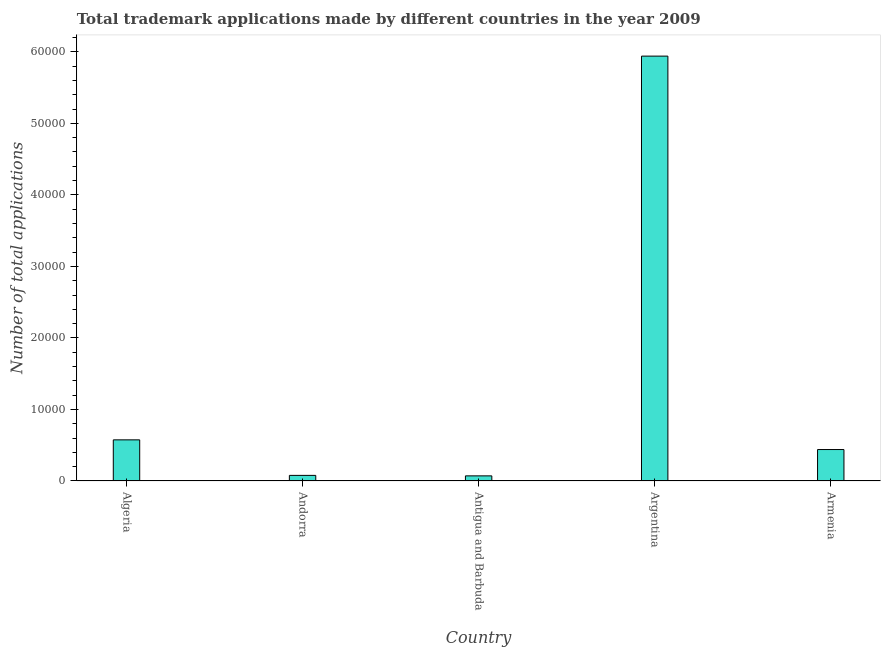Does the graph contain any zero values?
Provide a short and direct response. No. What is the title of the graph?
Your answer should be very brief. Total trademark applications made by different countries in the year 2009. What is the label or title of the X-axis?
Provide a succinct answer. Country. What is the label or title of the Y-axis?
Provide a short and direct response. Number of total applications. What is the number of trademark applications in Antigua and Barbuda?
Your response must be concise. 716. Across all countries, what is the maximum number of trademark applications?
Make the answer very short. 5.94e+04. Across all countries, what is the minimum number of trademark applications?
Ensure brevity in your answer.  716. In which country was the number of trademark applications maximum?
Provide a succinct answer. Argentina. In which country was the number of trademark applications minimum?
Your answer should be compact. Antigua and Barbuda. What is the sum of the number of trademark applications?
Offer a terse response. 7.11e+04. What is the difference between the number of trademark applications in Andorra and Argentina?
Make the answer very short. -5.86e+04. What is the average number of trademark applications per country?
Offer a terse response. 1.42e+04. What is the median number of trademark applications?
Provide a short and direct response. 4398. What is the ratio of the number of trademark applications in Argentina to that in Armenia?
Provide a short and direct response. 13.51. Is the number of trademark applications in Andorra less than that in Antigua and Barbuda?
Provide a short and direct response. No. Is the difference between the number of trademark applications in Algeria and Armenia greater than the difference between any two countries?
Provide a succinct answer. No. What is the difference between the highest and the second highest number of trademark applications?
Offer a terse response. 5.37e+04. Is the sum of the number of trademark applications in Andorra and Antigua and Barbuda greater than the maximum number of trademark applications across all countries?
Ensure brevity in your answer.  No. What is the difference between the highest and the lowest number of trademark applications?
Offer a terse response. 5.87e+04. Are all the bars in the graph horizontal?
Provide a short and direct response. No. How many countries are there in the graph?
Provide a succinct answer. 5. Are the values on the major ticks of Y-axis written in scientific E-notation?
Your answer should be compact. No. What is the Number of total applications of Algeria?
Make the answer very short. 5752. What is the Number of total applications of Andorra?
Your answer should be very brief. 785. What is the Number of total applications in Antigua and Barbuda?
Your answer should be compact. 716. What is the Number of total applications in Argentina?
Offer a very short reply. 5.94e+04. What is the Number of total applications of Armenia?
Your response must be concise. 4398. What is the difference between the Number of total applications in Algeria and Andorra?
Make the answer very short. 4967. What is the difference between the Number of total applications in Algeria and Antigua and Barbuda?
Your response must be concise. 5036. What is the difference between the Number of total applications in Algeria and Argentina?
Make the answer very short. -5.37e+04. What is the difference between the Number of total applications in Algeria and Armenia?
Keep it short and to the point. 1354. What is the difference between the Number of total applications in Andorra and Argentina?
Provide a succinct answer. -5.86e+04. What is the difference between the Number of total applications in Andorra and Armenia?
Your response must be concise. -3613. What is the difference between the Number of total applications in Antigua and Barbuda and Argentina?
Offer a terse response. -5.87e+04. What is the difference between the Number of total applications in Antigua and Barbuda and Armenia?
Provide a short and direct response. -3682. What is the difference between the Number of total applications in Argentina and Armenia?
Your response must be concise. 5.50e+04. What is the ratio of the Number of total applications in Algeria to that in Andorra?
Your response must be concise. 7.33. What is the ratio of the Number of total applications in Algeria to that in Antigua and Barbuda?
Your response must be concise. 8.03. What is the ratio of the Number of total applications in Algeria to that in Argentina?
Your answer should be compact. 0.1. What is the ratio of the Number of total applications in Algeria to that in Armenia?
Ensure brevity in your answer.  1.31. What is the ratio of the Number of total applications in Andorra to that in Antigua and Barbuda?
Keep it short and to the point. 1.1. What is the ratio of the Number of total applications in Andorra to that in Argentina?
Ensure brevity in your answer.  0.01. What is the ratio of the Number of total applications in Andorra to that in Armenia?
Provide a succinct answer. 0.18. What is the ratio of the Number of total applications in Antigua and Barbuda to that in Argentina?
Give a very brief answer. 0.01. What is the ratio of the Number of total applications in Antigua and Barbuda to that in Armenia?
Your answer should be very brief. 0.16. What is the ratio of the Number of total applications in Argentina to that in Armenia?
Provide a short and direct response. 13.51. 